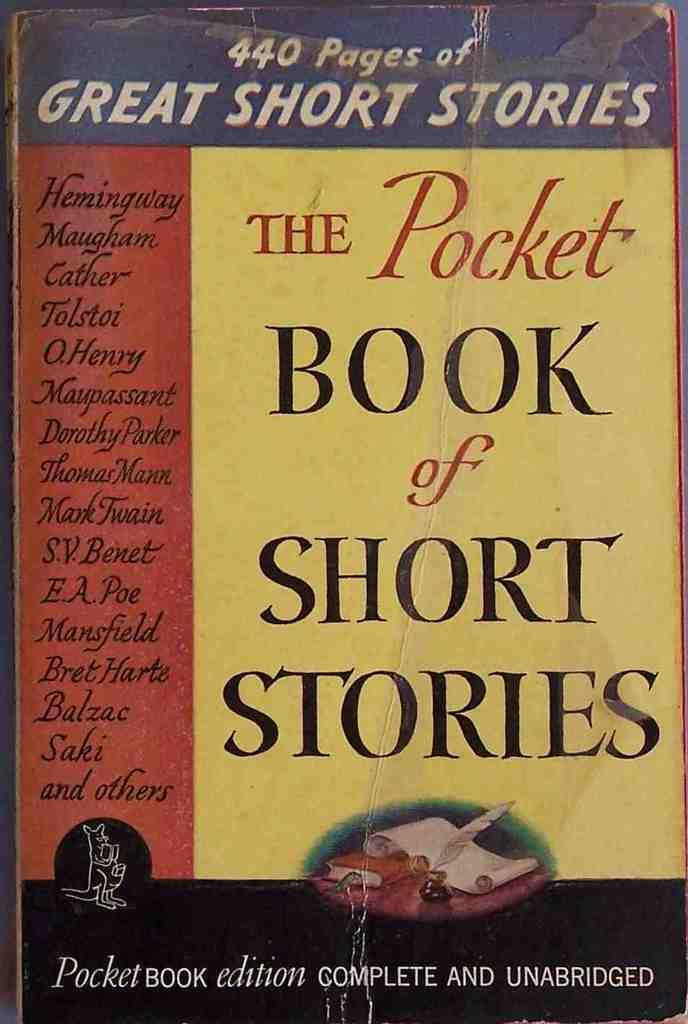<image>
Give a short and clear explanation of the subsequent image. The cover of the complete and unabridged edition of The Pocket Book of Short Stories. 